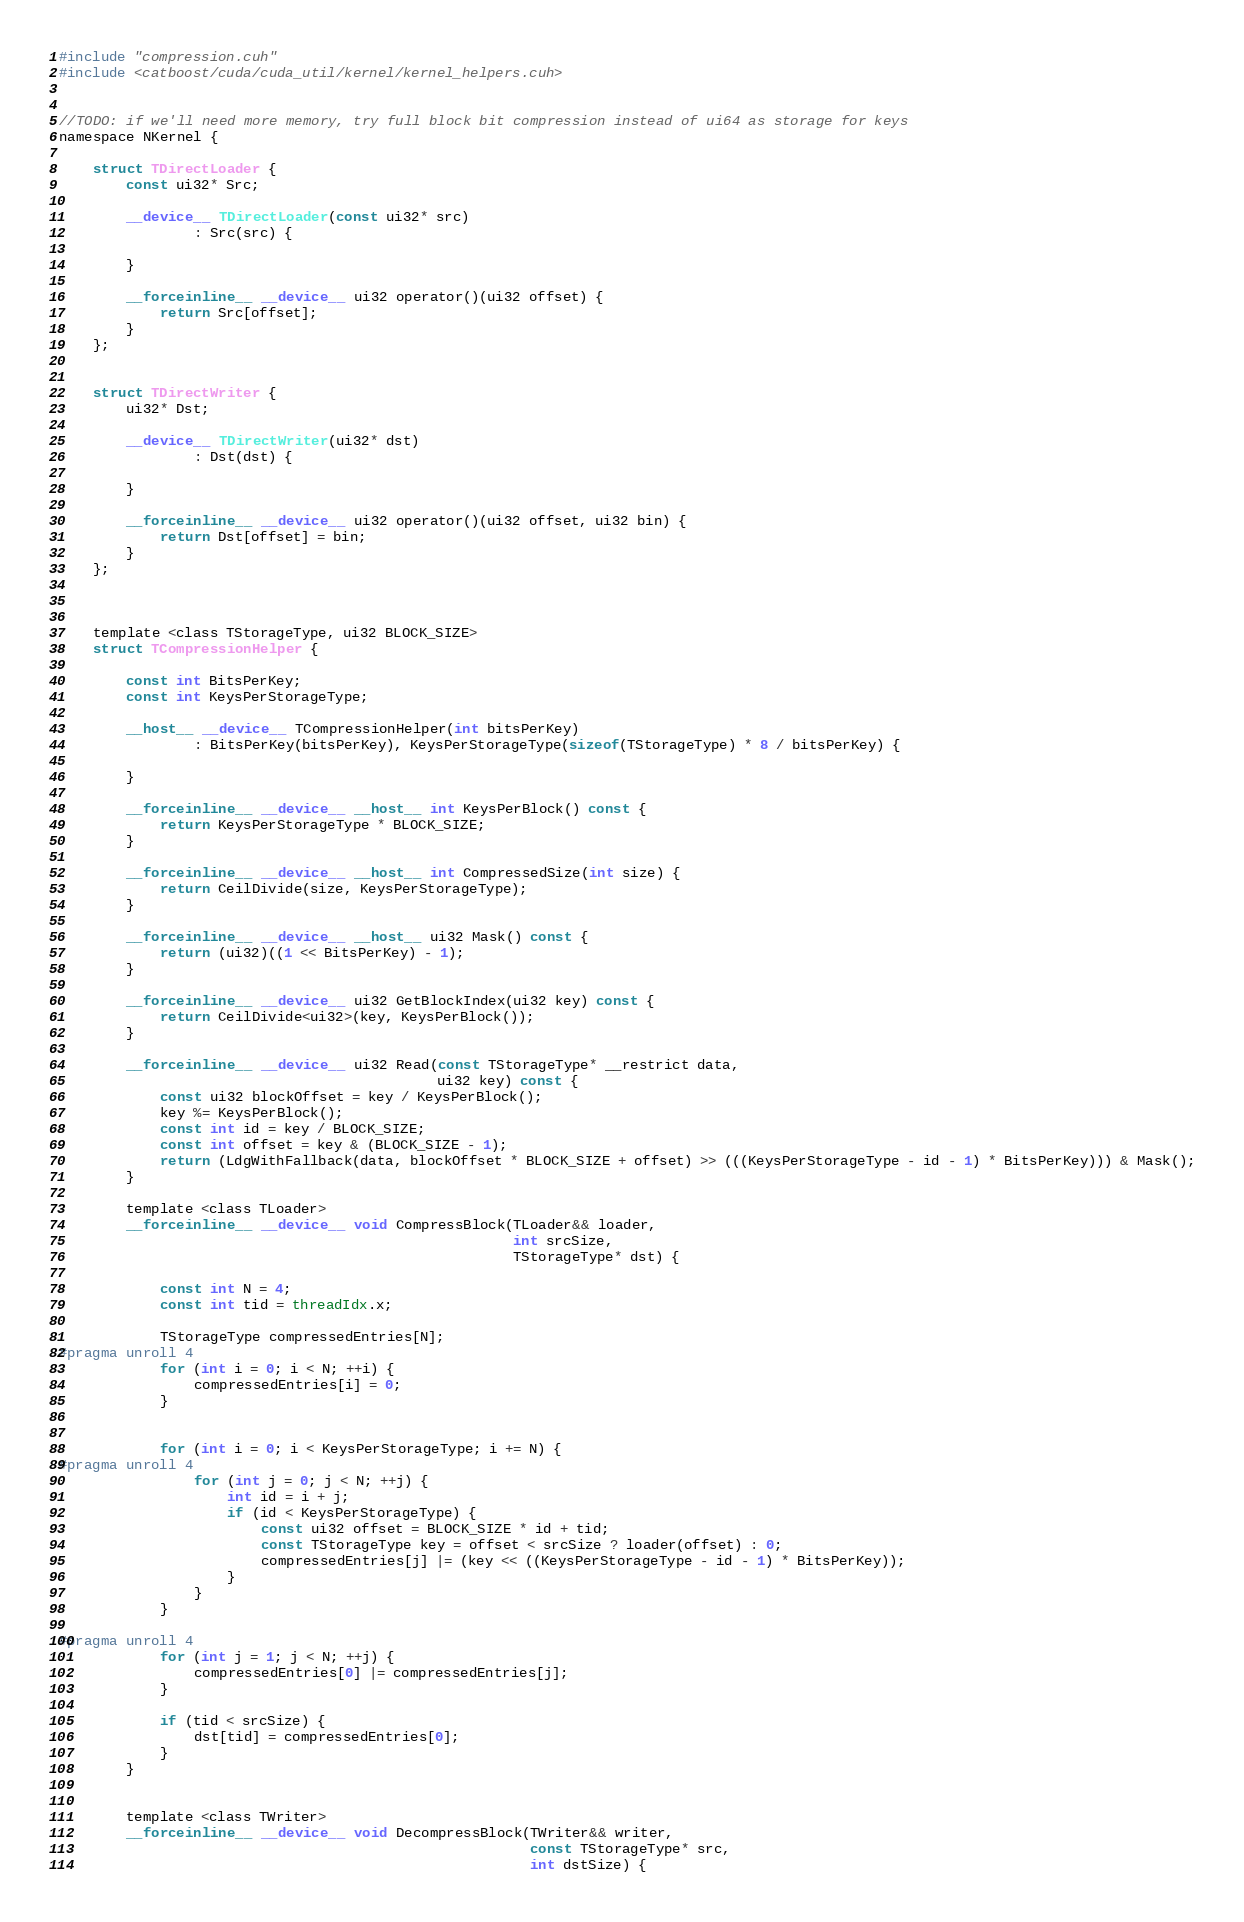<code> <loc_0><loc_0><loc_500><loc_500><_Cuda_>#include "compression.cuh"
#include <catboost/cuda/cuda_util/kernel/kernel_helpers.cuh>


//TODO: if we'll need more memory, try full block bit compression instead of ui64 as storage for keys
namespace NKernel {

    struct TDirectLoader {
        const ui32* Src;

        __device__ TDirectLoader(const ui32* src)
                : Src(src) {

        }

        __forceinline__ __device__ ui32 operator()(ui32 offset) {
            return Src[offset];
        }
    };


    struct TDirectWriter {
        ui32* Dst;

        __device__ TDirectWriter(ui32* dst)
                : Dst(dst) {

        }

        __forceinline__ __device__ ui32 operator()(ui32 offset, ui32 bin) {
            return Dst[offset] = bin;
        }
    };



    template <class TStorageType, ui32 BLOCK_SIZE>
    struct TCompressionHelper {

        const int BitsPerKey;
        const int KeysPerStorageType;

        __host__ __device__ TCompressionHelper(int bitsPerKey)
                : BitsPerKey(bitsPerKey), KeysPerStorageType(sizeof(TStorageType) * 8 / bitsPerKey) {

        }

        __forceinline__ __device__ __host__ int KeysPerBlock() const {
            return KeysPerStorageType * BLOCK_SIZE;
        }

        __forceinline__ __device__ __host__ int CompressedSize(int size) {
            return CeilDivide(size, KeysPerStorageType);
        }

        __forceinline__ __device__ __host__ ui32 Mask() const {
            return (ui32)((1 << BitsPerKey) - 1);
        }

        __forceinline__ __device__ ui32 GetBlockIndex(ui32 key) const {
            return CeilDivide<ui32>(key, KeysPerBlock());
        }

        __forceinline__ __device__ ui32 Read(const TStorageType* __restrict data,
                                             ui32 key) const {
            const ui32 blockOffset = key / KeysPerBlock();
            key %= KeysPerBlock();
            const int id = key / BLOCK_SIZE;
            const int offset = key & (BLOCK_SIZE - 1);
            return (LdgWithFallback(data, blockOffset * BLOCK_SIZE + offset) >> (((KeysPerStorageType - id - 1) * BitsPerKey))) & Mask();
        }

        template <class TLoader>
        __forceinline__ __device__ void CompressBlock(TLoader&& loader,
                                                      int srcSize,
                                                      TStorageType* dst) {

            const int N = 4;
            const int tid = threadIdx.x;

            TStorageType compressedEntries[N];
#pragma unroll 4
            for (int i = 0; i < N; ++i) {
                compressedEntries[i] = 0;
            }


            for (int i = 0; i < KeysPerStorageType; i += N) {
#pragma unroll 4
                for (int j = 0; j < N; ++j) {
                    int id = i + j;
                    if (id < KeysPerStorageType) {
                        const ui32 offset = BLOCK_SIZE * id + tid;
                        const TStorageType key = offset < srcSize ? loader(offset) : 0;
                        compressedEntries[j] |= (key << ((KeysPerStorageType - id - 1) * BitsPerKey));
                    }
                }
            }

#pragma unroll 4
            for (int j = 1; j < N; ++j) {
                compressedEntries[0] |= compressedEntries[j];
            }

            if (tid < srcSize) {
                dst[tid] = compressedEntries[0];
            }
        }


        template <class TWriter>
        __forceinline__ __device__ void DecompressBlock(TWriter&& writer,
                                                        const TStorageType* src,
                                                        int dstSize) {</code> 